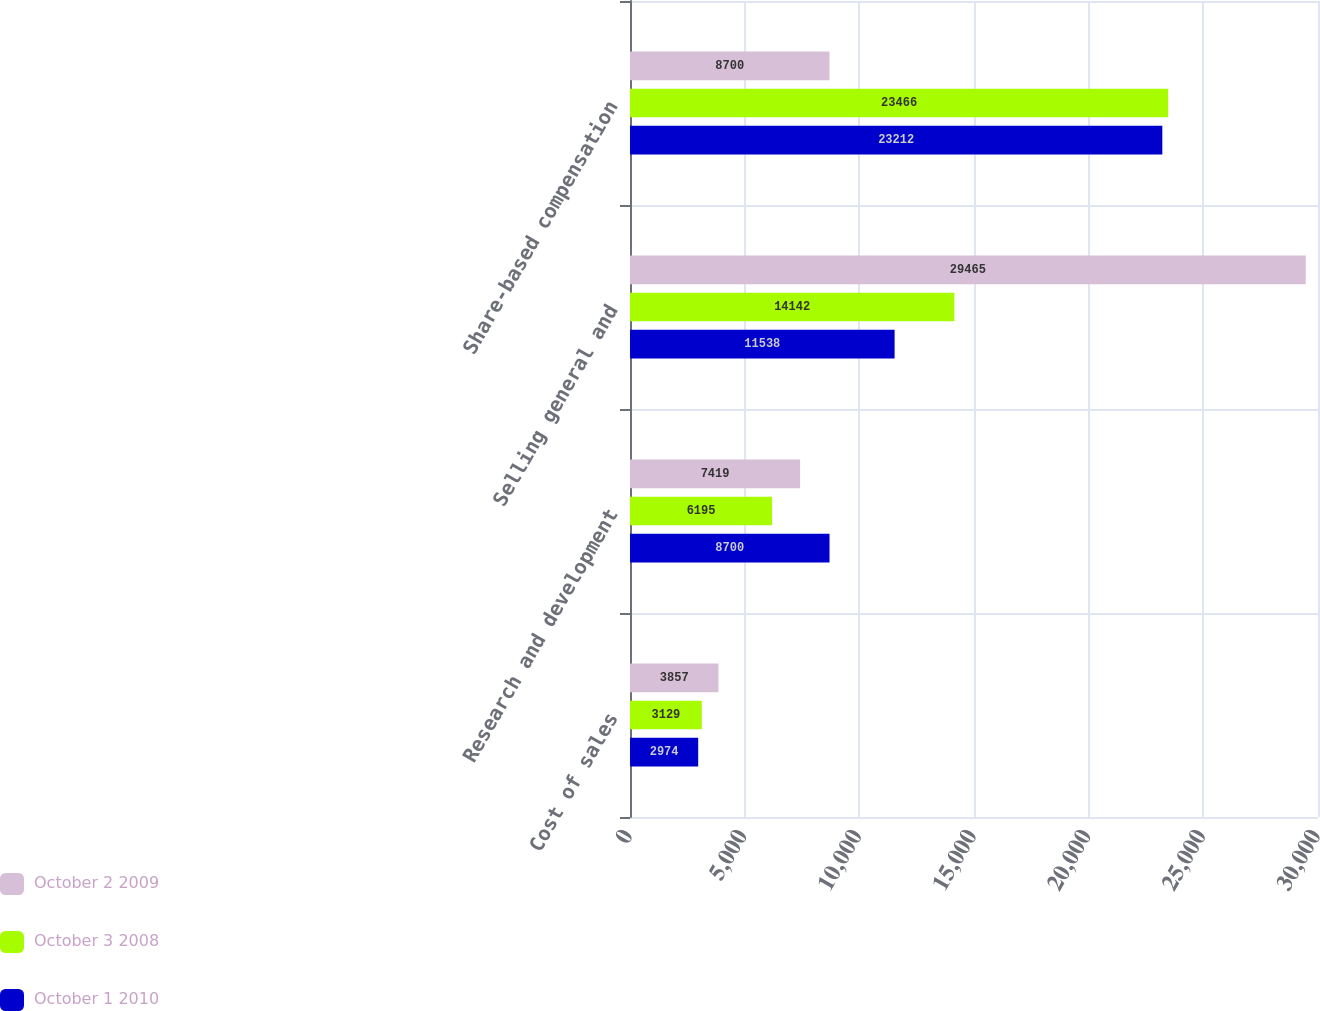<chart> <loc_0><loc_0><loc_500><loc_500><stacked_bar_chart><ecel><fcel>Cost of sales<fcel>Research and development<fcel>Selling general and<fcel>Share-based compensation<nl><fcel>October 2 2009<fcel>3857<fcel>7419<fcel>29465<fcel>8700<nl><fcel>October 3 2008<fcel>3129<fcel>6195<fcel>14142<fcel>23466<nl><fcel>October 1 2010<fcel>2974<fcel>8700<fcel>11538<fcel>23212<nl></chart> 